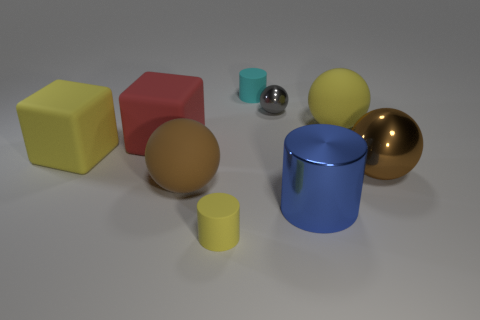Subtract all big brown rubber balls. How many balls are left? 3 Subtract all yellow spheres. How many spheres are left? 3 Subtract all cylinders. How many objects are left? 6 Add 1 tiny yellow things. How many objects exist? 10 Subtract 2 cylinders. How many cylinders are left? 1 Subtract all big blue matte cylinders. Subtract all matte cubes. How many objects are left? 7 Add 8 brown matte objects. How many brown matte objects are left? 9 Add 3 blue things. How many blue things exist? 4 Subtract 0 gray cylinders. How many objects are left? 9 Subtract all purple blocks. Subtract all green spheres. How many blocks are left? 2 